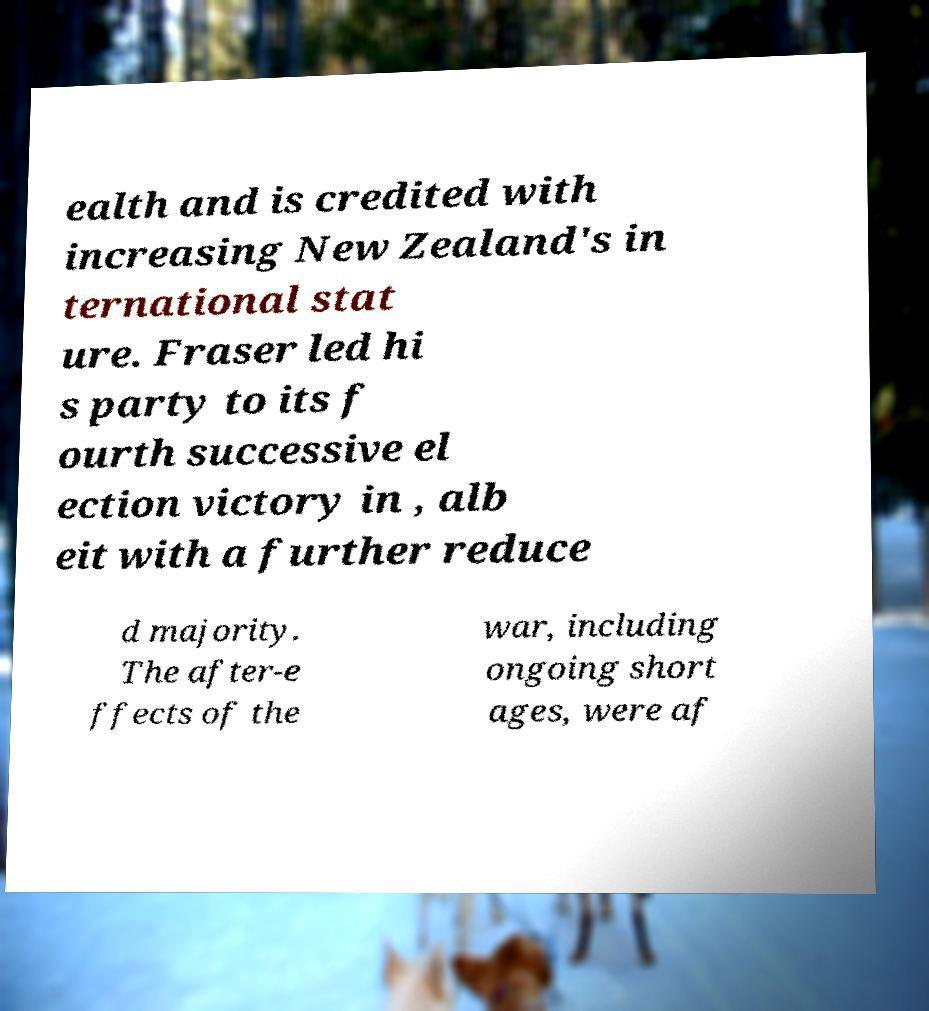Please read and relay the text visible in this image. What does it say? ealth and is credited with increasing New Zealand's in ternational stat ure. Fraser led hi s party to its f ourth successive el ection victory in , alb eit with a further reduce d majority. The after-e ffects of the war, including ongoing short ages, were af 